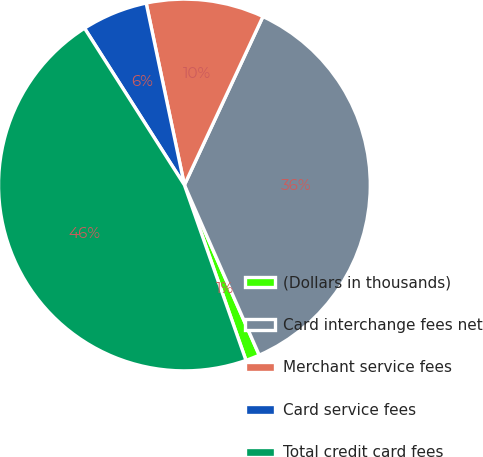Convert chart. <chart><loc_0><loc_0><loc_500><loc_500><pie_chart><fcel>(Dollars in thousands)<fcel>Card interchange fees net<fcel>Merchant service fees<fcel>Card service fees<fcel>Total credit card fees<nl><fcel>1.22%<fcel>36.46%<fcel>10.24%<fcel>5.73%<fcel>46.34%<nl></chart> 